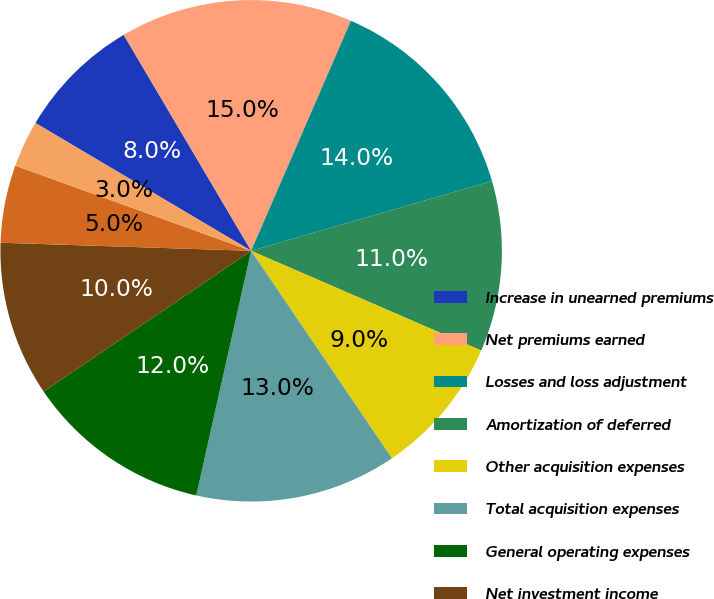<chart> <loc_0><loc_0><loc_500><loc_500><pie_chart><fcel>Increase in unearned premiums<fcel>Net premiums earned<fcel>Losses and loss adjustment<fcel>Amortization of deferred<fcel>Other acquisition expenses<fcel>Total acquisition expenses<fcel>General operating expenses<fcel>Net investment income<fcel>Loss ratio<fcel>Acquisition ratio<nl><fcel>8.0%<fcel>15.0%<fcel>14.0%<fcel>11.0%<fcel>9.0%<fcel>13.0%<fcel>12.0%<fcel>10.0%<fcel>5.0%<fcel>3.0%<nl></chart> 